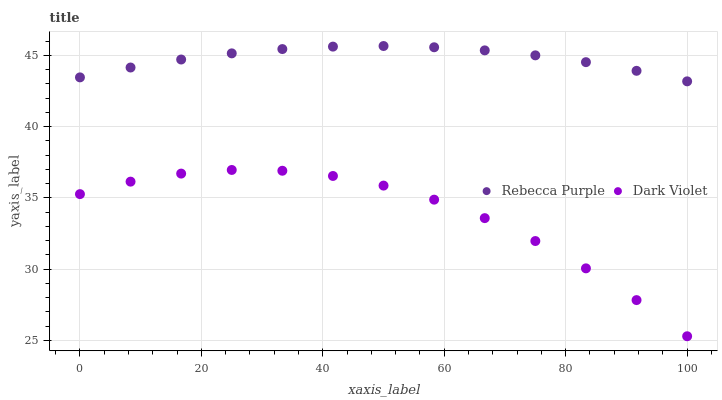Does Dark Violet have the minimum area under the curve?
Answer yes or no. Yes. Does Rebecca Purple have the maximum area under the curve?
Answer yes or no. Yes. Does Dark Violet have the maximum area under the curve?
Answer yes or no. No. Is Rebecca Purple the smoothest?
Answer yes or no. Yes. Is Dark Violet the roughest?
Answer yes or no. Yes. Is Dark Violet the smoothest?
Answer yes or no. No. Does Dark Violet have the lowest value?
Answer yes or no. Yes. Does Rebecca Purple have the highest value?
Answer yes or no. Yes. Does Dark Violet have the highest value?
Answer yes or no. No. Is Dark Violet less than Rebecca Purple?
Answer yes or no. Yes. Is Rebecca Purple greater than Dark Violet?
Answer yes or no. Yes. Does Dark Violet intersect Rebecca Purple?
Answer yes or no. No. 